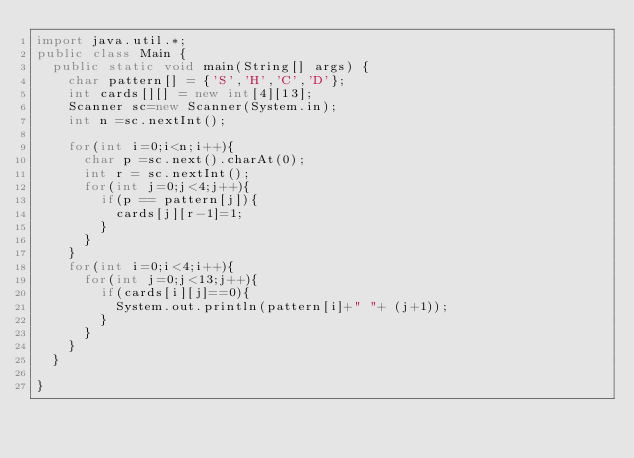<code> <loc_0><loc_0><loc_500><loc_500><_Java_>import java.util.*;
public class Main {
	public static void main(String[] args) {
		char pattern[] = {'S','H','C','D'};
		int cards[][] = new int[4][13];
		Scanner sc=new Scanner(System.in);
		int n =sc.nextInt();
		
		for(int i=0;i<n;i++){
			char p =sc.next().charAt(0);
			int r = sc.nextInt();
			for(int j=0;j<4;j++){
				if(p == pattern[j]){
					cards[j][r-1]=1;
				}
			}
		}
		for(int i=0;i<4;i++){
			for(int j=0;j<13;j++){
				if(cards[i][j]==0){
					System.out.println(pattern[i]+" "+ (j+1));
				}
			}
		}
	}

}</code> 